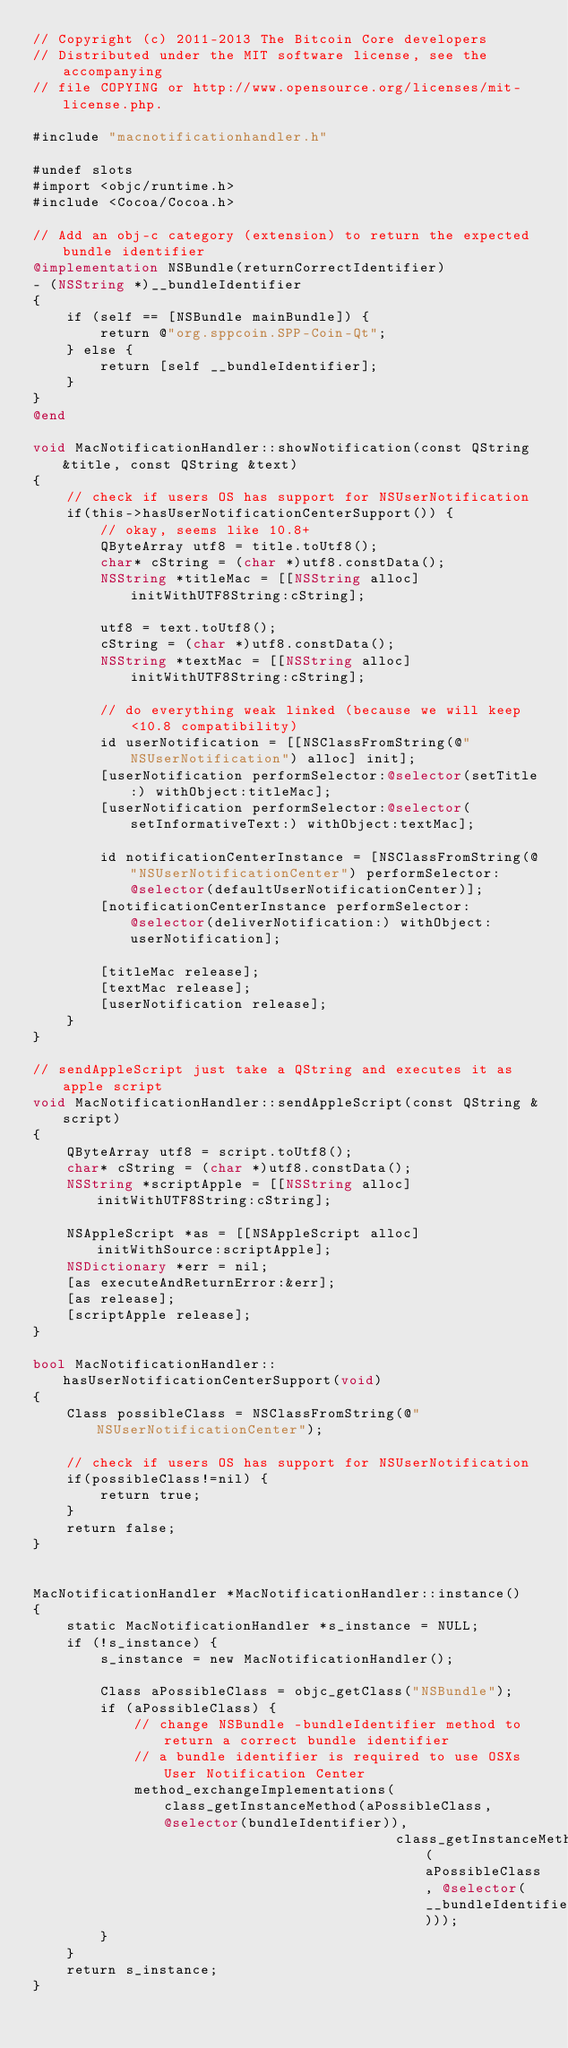Convert code to text. <code><loc_0><loc_0><loc_500><loc_500><_ObjectiveC_>// Copyright (c) 2011-2013 The Bitcoin Core developers
// Distributed under the MIT software license, see the accompanying
// file COPYING or http://www.opensource.org/licenses/mit-license.php.

#include "macnotificationhandler.h"

#undef slots
#import <objc/runtime.h>
#include <Cocoa/Cocoa.h>

// Add an obj-c category (extension) to return the expected bundle identifier
@implementation NSBundle(returnCorrectIdentifier)
- (NSString *)__bundleIdentifier
{
    if (self == [NSBundle mainBundle]) {
        return @"org.sppcoin.SPP-Coin-Qt";
    } else {
        return [self __bundleIdentifier];
    }
}
@end

void MacNotificationHandler::showNotification(const QString &title, const QString &text)
{
    // check if users OS has support for NSUserNotification
    if(this->hasUserNotificationCenterSupport()) {
        // okay, seems like 10.8+
        QByteArray utf8 = title.toUtf8();
        char* cString = (char *)utf8.constData();
        NSString *titleMac = [[NSString alloc] initWithUTF8String:cString];

        utf8 = text.toUtf8();
        cString = (char *)utf8.constData();
        NSString *textMac = [[NSString alloc] initWithUTF8String:cString];

        // do everything weak linked (because we will keep <10.8 compatibility)
        id userNotification = [[NSClassFromString(@"NSUserNotification") alloc] init];
        [userNotification performSelector:@selector(setTitle:) withObject:titleMac];
        [userNotification performSelector:@selector(setInformativeText:) withObject:textMac];

        id notificationCenterInstance = [NSClassFromString(@"NSUserNotificationCenter") performSelector:@selector(defaultUserNotificationCenter)];
        [notificationCenterInstance performSelector:@selector(deliverNotification:) withObject:userNotification];

        [titleMac release];
        [textMac release];
        [userNotification release];
    }
}

// sendAppleScript just take a QString and executes it as apple script
void MacNotificationHandler::sendAppleScript(const QString &script)
{
    QByteArray utf8 = script.toUtf8();
    char* cString = (char *)utf8.constData();
    NSString *scriptApple = [[NSString alloc] initWithUTF8String:cString];

    NSAppleScript *as = [[NSAppleScript alloc] initWithSource:scriptApple];
    NSDictionary *err = nil;
    [as executeAndReturnError:&err];
    [as release];
    [scriptApple release];
}

bool MacNotificationHandler::hasUserNotificationCenterSupport(void)
{
    Class possibleClass = NSClassFromString(@"NSUserNotificationCenter");

    // check if users OS has support for NSUserNotification
    if(possibleClass!=nil) {
        return true;
    }
    return false;
}


MacNotificationHandler *MacNotificationHandler::instance()
{
    static MacNotificationHandler *s_instance = NULL;
    if (!s_instance) {
        s_instance = new MacNotificationHandler();
        
        Class aPossibleClass = objc_getClass("NSBundle");
        if (aPossibleClass) {
            // change NSBundle -bundleIdentifier method to return a correct bundle identifier
            // a bundle identifier is required to use OSXs User Notification Center
            method_exchangeImplementations(class_getInstanceMethod(aPossibleClass, @selector(bundleIdentifier)),
                                           class_getInstanceMethod(aPossibleClass, @selector(__bundleIdentifier)));
        }
    }
    return s_instance;
}
</code> 